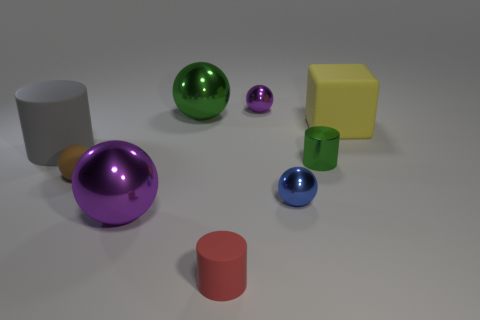Is there anything else that has the same shape as the yellow object?
Ensure brevity in your answer.  No. Does the tiny red object have the same shape as the big metallic thing that is in front of the blue metallic object?
Provide a succinct answer. No. There is a thing that is the same color as the small shiny cylinder; what shape is it?
Ensure brevity in your answer.  Sphere. How many small red cylinders are left of the tiny blue metal ball behind the small object that is in front of the blue sphere?
Make the answer very short. 1. How big is the cylinder right of the small object that is behind the gray rubber cylinder?
Make the answer very short. Small. What size is the red thing that is made of the same material as the yellow cube?
Offer a terse response. Small. What is the shape of the metallic object that is both right of the large purple sphere and in front of the rubber ball?
Provide a succinct answer. Sphere. Are there an equal number of large gray cylinders that are behind the big green ball and brown rubber cubes?
Provide a short and direct response. Yes. What number of objects are either tiny green metallic cylinders or tiny cylinders behind the tiny brown matte sphere?
Ensure brevity in your answer.  1. Is there a green thing that has the same shape as the big gray rubber thing?
Offer a terse response. Yes. 